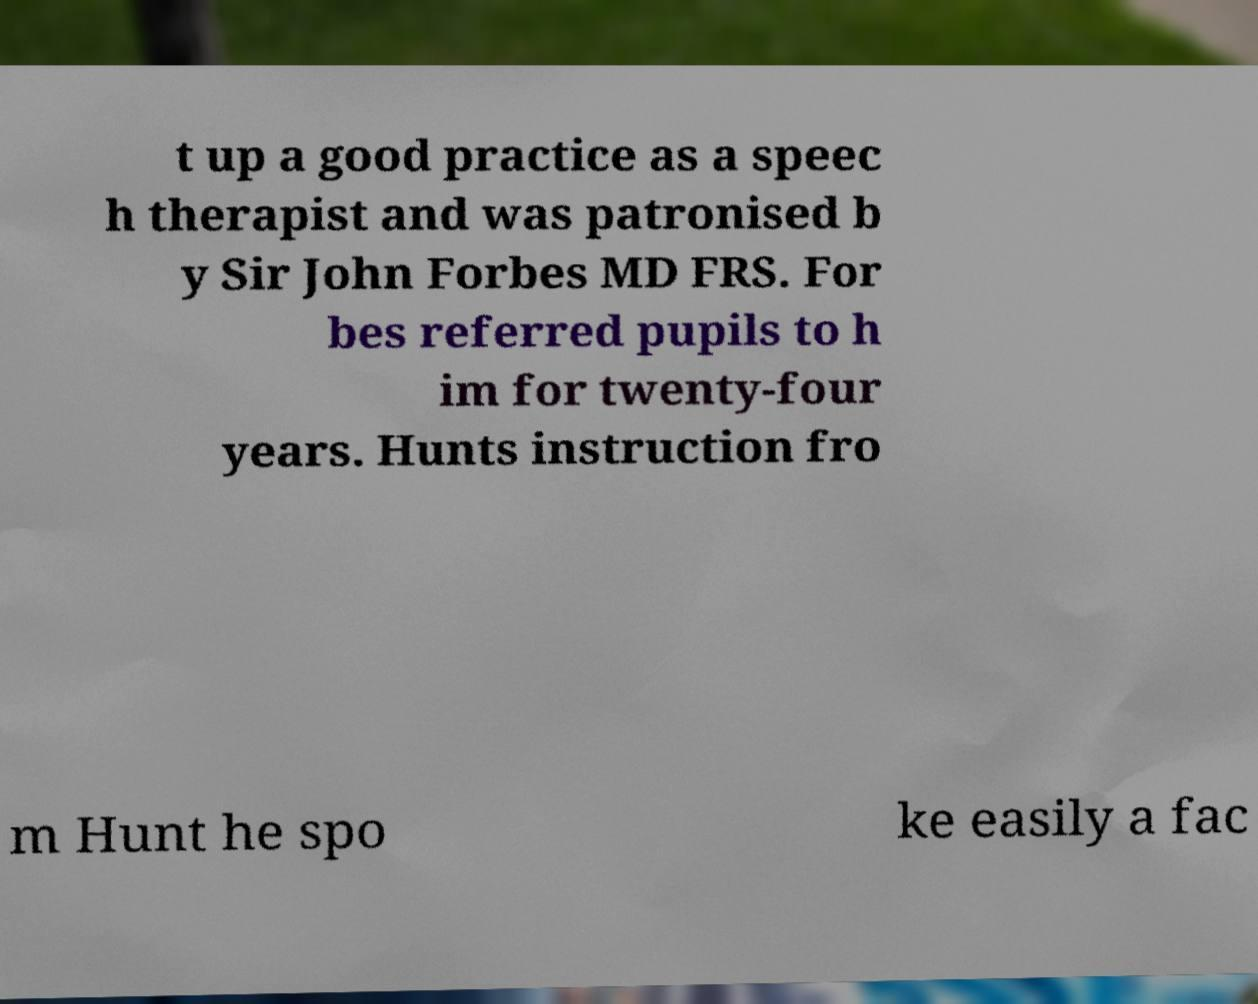Please identify and transcribe the text found in this image. t up a good practice as a speec h therapist and was patronised b y Sir John Forbes MD FRS. For bes referred pupils to h im for twenty-four years. Hunts instruction fro m Hunt he spo ke easily a fac 